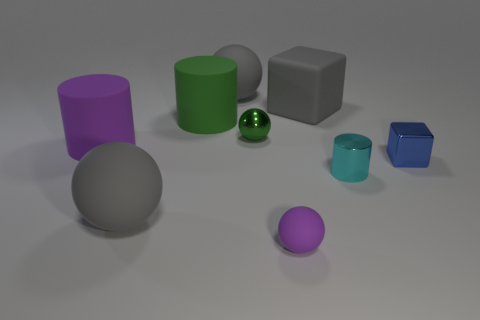Subtract all large rubber cylinders. How many cylinders are left? 1 Subtract all blue blocks. How many blocks are left? 1 Subtract all blocks. How many objects are left? 7 Subtract 3 cylinders. How many cylinders are left? 0 Subtract all gray balls. Subtract all cyan cubes. How many balls are left? 2 Subtract all green balls. How many green cylinders are left? 1 Subtract all blue cubes. Subtract all small metallic balls. How many objects are left? 7 Add 3 large green matte cylinders. How many large green matte cylinders are left? 4 Add 6 small purple rubber spheres. How many small purple rubber spheres exist? 7 Subtract 0 brown cubes. How many objects are left? 9 